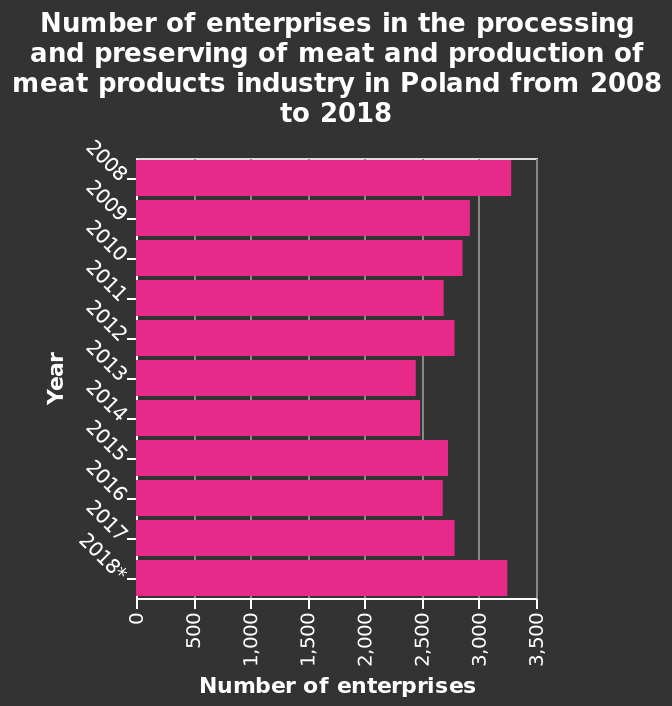<image>
What is represented on the y-axis of the diagram?   The y-axis represents the categorical scale for the years, ranging from 2008 to 2018, labeled as "Year." How has the number of meat processing and production enterprises changed since 2008?  The number of meat processing and production enterprises generally declined since 2008. 